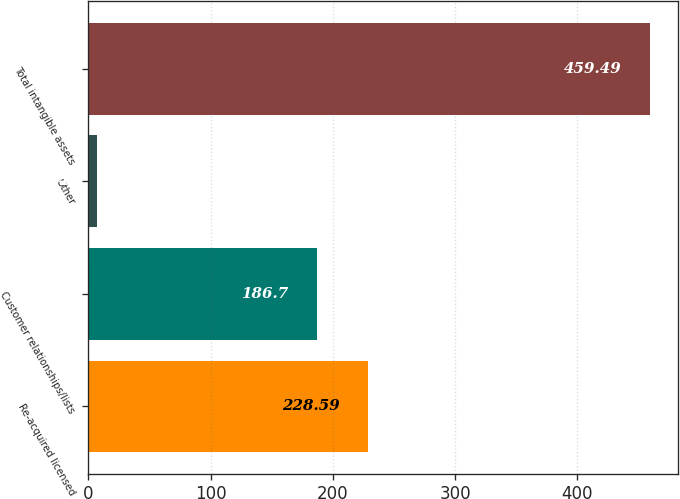Convert chart to OTSL. <chart><loc_0><loc_0><loc_500><loc_500><bar_chart><fcel>Re-acquired licensed<fcel>Customer relationships/lists<fcel>Other<fcel>Total intangible assets<nl><fcel>228.59<fcel>186.7<fcel>7.4<fcel>459.49<nl></chart> 